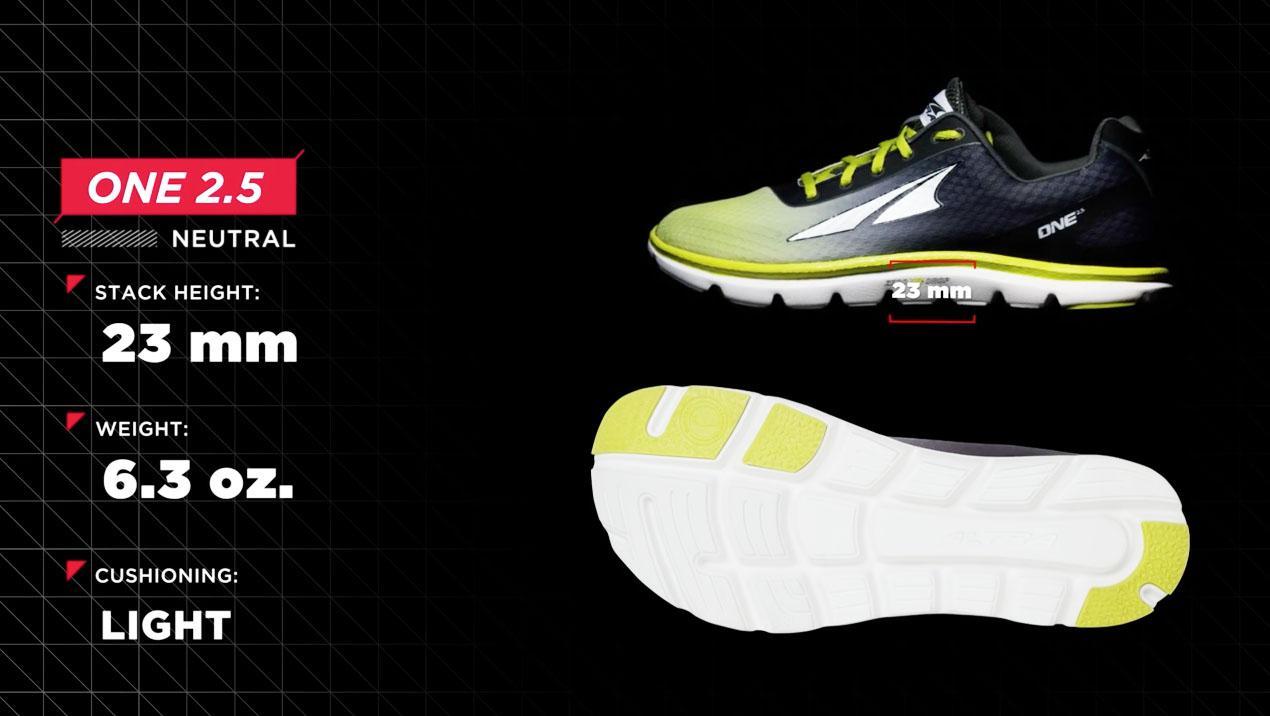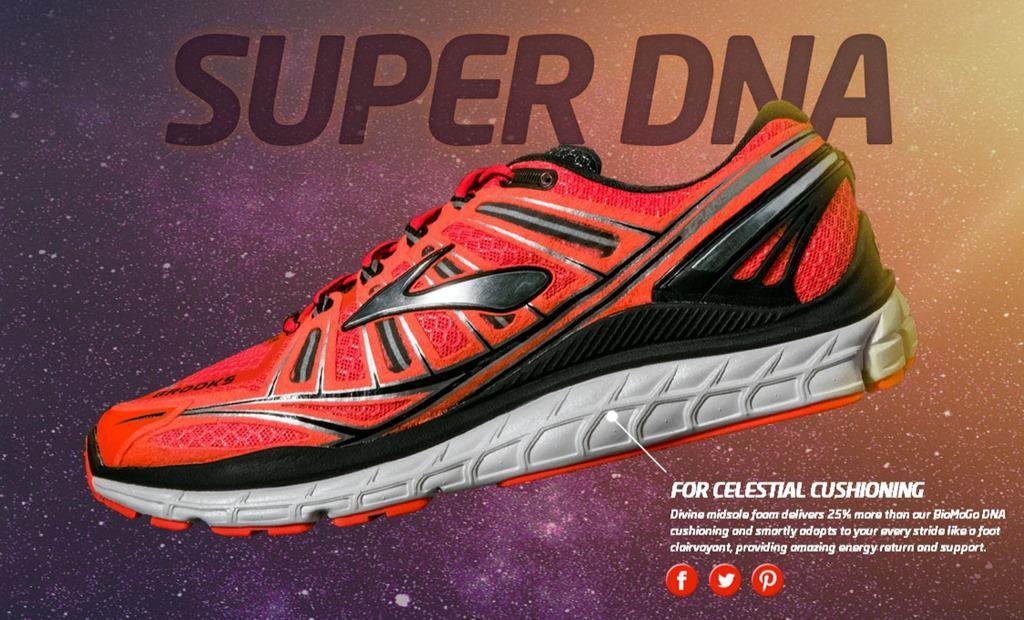The first image is the image on the left, the second image is the image on the right. For the images displayed, is the sentence "There is exactly two sports tennis shoes in the left image." factually correct? Answer yes or no. Yes. The first image is the image on the left, the second image is the image on the right. For the images displayed, is the sentence "All shoes face rightward and all shoes are displayed without their matched partner." factually correct? Answer yes or no. No. 